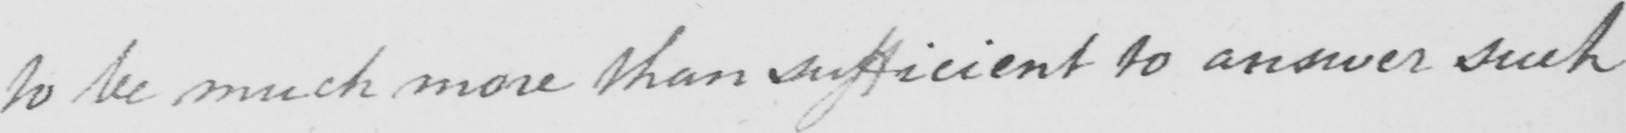Can you read and transcribe this handwriting? to be much more than sufficient to answer such 